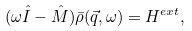<formula> <loc_0><loc_0><loc_500><loc_500>( \omega \hat { I } - \hat { M } ) \bar { \rho } ( \vec { q } , \omega ) = H ^ { e x t } ,</formula> 